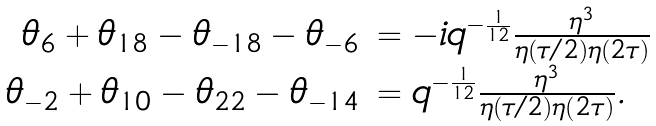<formula> <loc_0><loc_0><loc_500><loc_500>\begin{array} { r l } { { \theta _ { 6 } + \theta _ { 1 8 } - \theta _ { - 1 8 } - \theta _ { - 6 } } } & { { = - i q ^ { - { \frac { 1 } { 1 2 } } } { \frac { \eta ^ { 3 } } { \eta ( \tau / 2 ) \eta ( 2 \tau ) } } } } \\ { { \theta _ { - 2 } + \theta _ { 1 0 } - \theta _ { 2 2 } - \theta _ { - 1 4 } } } & { { = q ^ { - { \frac { 1 } { 1 2 } } } { \frac { \eta ^ { 3 } } { \eta ( \tau / 2 ) \eta ( 2 \tau ) } } . } } \end{array}</formula> 